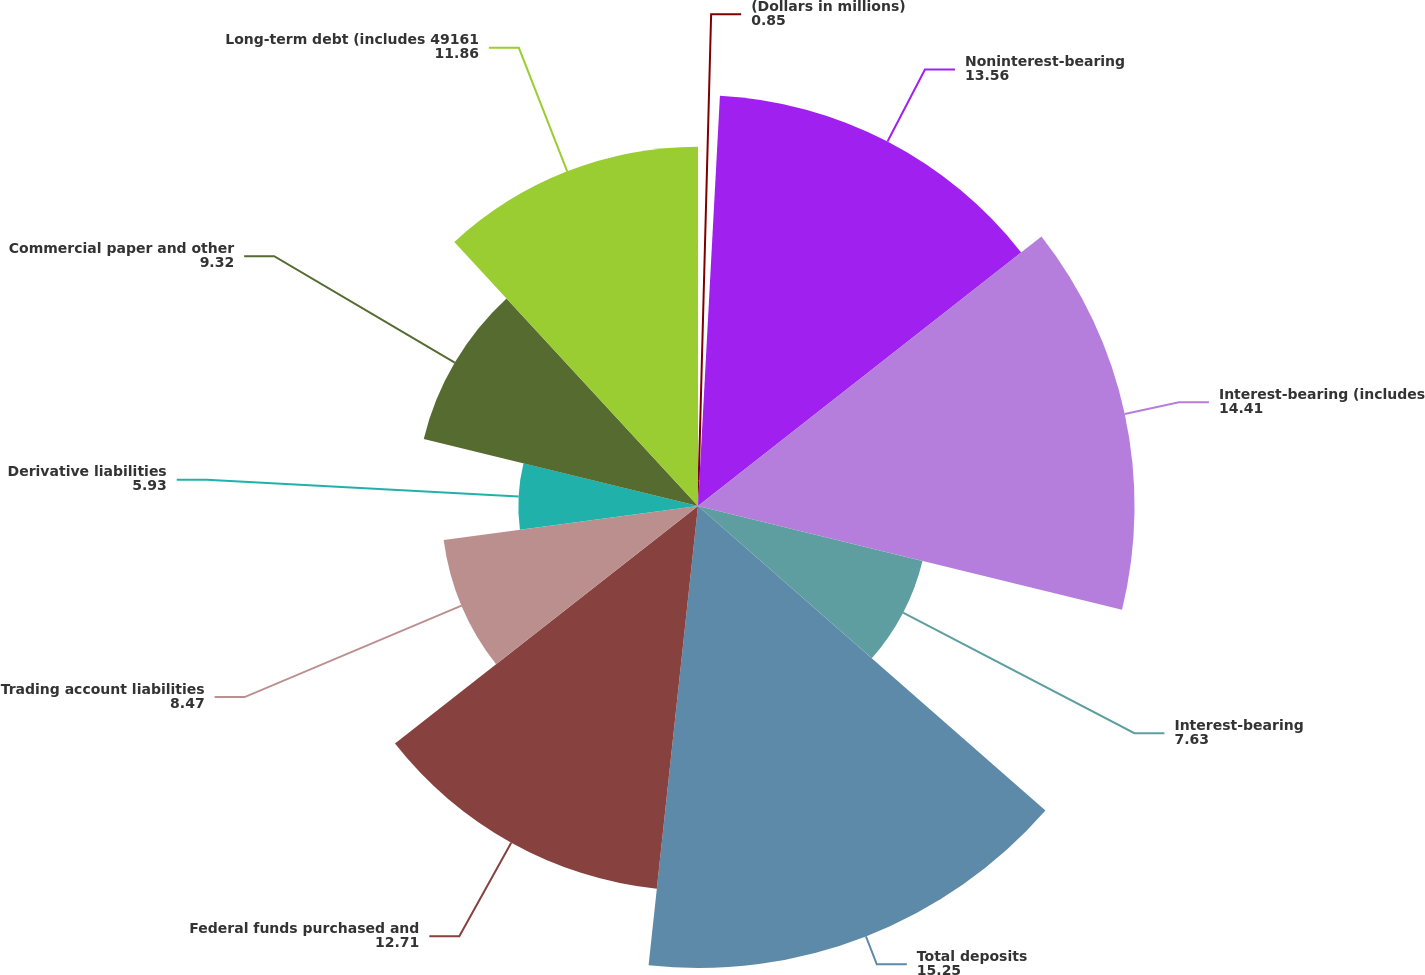Convert chart. <chart><loc_0><loc_0><loc_500><loc_500><pie_chart><fcel>(Dollars in millions)<fcel>Noninterest-bearing<fcel>Interest-bearing (includes<fcel>Interest-bearing<fcel>Total deposits<fcel>Federal funds purchased and<fcel>Trading account liabilities<fcel>Derivative liabilities<fcel>Commercial paper and other<fcel>Long-term debt (includes 49161<nl><fcel>0.85%<fcel>13.56%<fcel>14.41%<fcel>7.63%<fcel>15.25%<fcel>12.71%<fcel>8.47%<fcel>5.93%<fcel>9.32%<fcel>11.86%<nl></chart> 